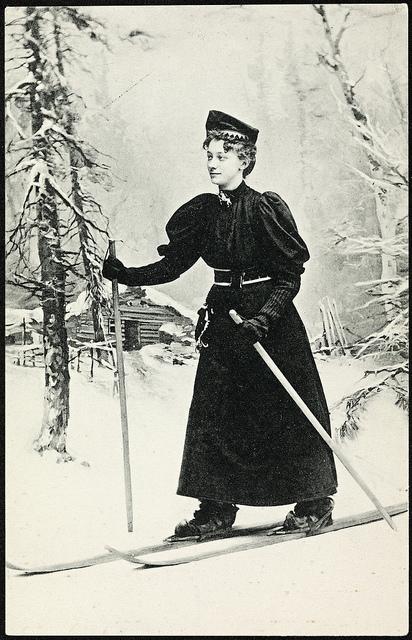Is this woman skiing?
Short answer required. Yes. Is this woman wearing yoga pants?
Keep it brief. No. Is she wearing glasses?
Write a very short answer. No. Is this a new photo?
Short answer required. No. 